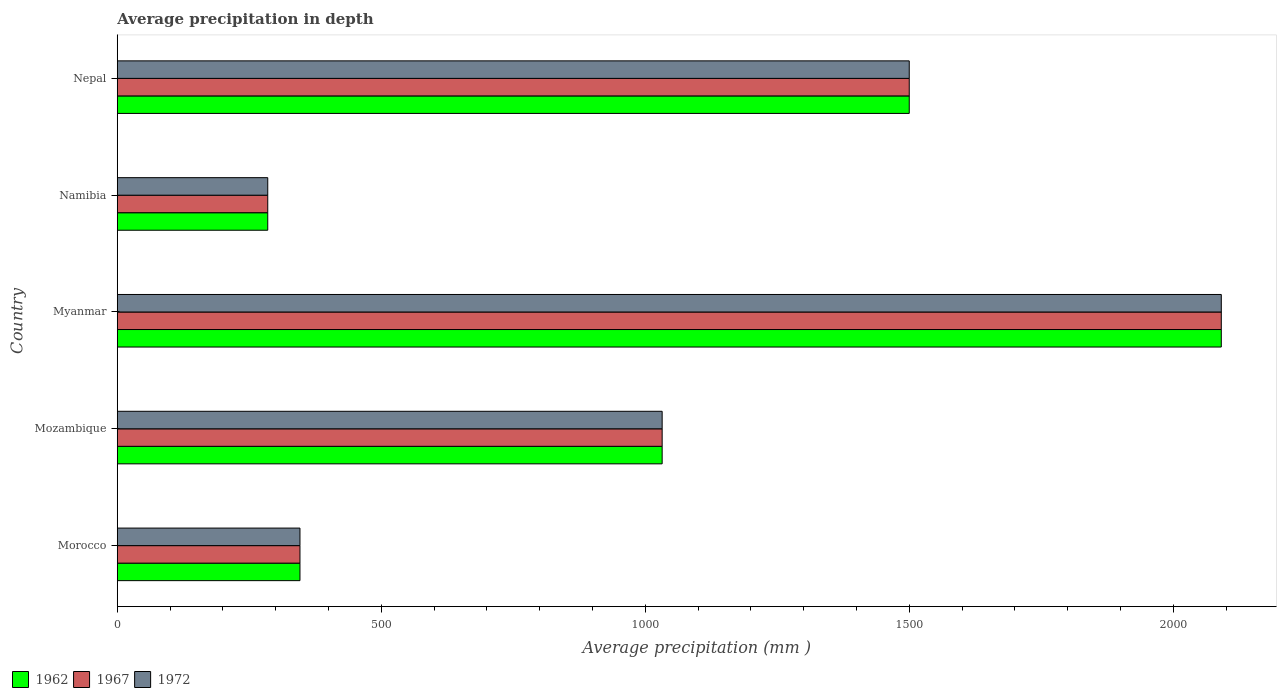Are the number of bars per tick equal to the number of legend labels?
Offer a very short reply. Yes. Are the number of bars on each tick of the Y-axis equal?
Your response must be concise. Yes. What is the label of the 3rd group of bars from the top?
Make the answer very short. Myanmar. In how many cases, is the number of bars for a given country not equal to the number of legend labels?
Provide a succinct answer. 0. What is the average precipitation in 1962 in Namibia?
Offer a terse response. 285. Across all countries, what is the maximum average precipitation in 1972?
Give a very brief answer. 2091. Across all countries, what is the minimum average precipitation in 1962?
Provide a short and direct response. 285. In which country was the average precipitation in 1962 maximum?
Your answer should be compact. Myanmar. In which country was the average precipitation in 1967 minimum?
Your answer should be compact. Namibia. What is the total average precipitation in 1967 in the graph?
Keep it short and to the point. 5254. What is the difference between the average precipitation in 1962 in Mozambique and that in Namibia?
Provide a short and direct response. 747. What is the difference between the average precipitation in 1967 in Namibia and the average precipitation in 1972 in Morocco?
Ensure brevity in your answer.  -61. What is the average average precipitation in 1962 per country?
Keep it short and to the point. 1050.8. What is the ratio of the average precipitation in 1962 in Mozambique to that in Namibia?
Provide a short and direct response. 3.62. What is the difference between the highest and the second highest average precipitation in 1972?
Make the answer very short. 591. What is the difference between the highest and the lowest average precipitation in 1972?
Make the answer very short. 1806. What does the 1st bar from the top in Myanmar represents?
Offer a very short reply. 1972. Is it the case that in every country, the sum of the average precipitation in 1962 and average precipitation in 1972 is greater than the average precipitation in 1967?
Offer a terse response. Yes. How many bars are there?
Make the answer very short. 15. Are the values on the major ticks of X-axis written in scientific E-notation?
Offer a very short reply. No. Does the graph contain any zero values?
Keep it short and to the point. No. What is the title of the graph?
Give a very brief answer. Average precipitation in depth. What is the label or title of the X-axis?
Your answer should be compact. Average precipitation (mm ). What is the Average precipitation (mm ) of 1962 in Morocco?
Give a very brief answer. 346. What is the Average precipitation (mm ) of 1967 in Morocco?
Provide a short and direct response. 346. What is the Average precipitation (mm ) of 1972 in Morocco?
Provide a succinct answer. 346. What is the Average precipitation (mm ) of 1962 in Mozambique?
Ensure brevity in your answer.  1032. What is the Average precipitation (mm ) of 1967 in Mozambique?
Your answer should be compact. 1032. What is the Average precipitation (mm ) of 1972 in Mozambique?
Keep it short and to the point. 1032. What is the Average precipitation (mm ) of 1962 in Myanmar?
Your answer should be compact. 2091. What is the Average precipitation (mm ) of 1967 in Myanmar?
Make the answer very short. 2091. What is the Average precipitation (mm ) in 1972 in Myanmar?
Your answer should be compact. 2091. What is the Average precipitation (mm ) in 1962 in Namibia?
Keep it short and to the point. 285. What is the Average precipitation (mm ) of 1967 in Namibia?
Offer a very short reply. 285. What is the Average precipitation (mm ) of 1972 in Namibia?
Make the answer very short. 285. What is the Average precipitation (mm ) of 1962 in Nepal?
Your response must be concise. 1500. What is the Average precipitation (mm ) of 1967 in Nepal?
Give a very brief answer. 1500. What is the Average precipitation (mm ) in 1972 in Nepal?
Ensure brevity in your answer.  1500. Across all countries, what is the maximum Average precipitation (mm ) of 1962?
Your answer should be compact. 2091. Across all countries, what is the maximum Average precipitation (mm ) of 1967?
Provide a succinct answer. 2091. Across all countries, what is the maximum Average precipitation (mm ) of 1972?
Provide a succinct answer. 2091. Across all countries, what is the minimum Average precipitation (mm ) in 1962?
Ensure brevity in your answer.  285. Across all countries, what is the minimum Average precipitation (mm ) of 1967?
Ensure brevity in your answer.  285. Across all countries, what is the minimum Average precipitation (mm ) of 1972?
Your answer should be compact. 285. What is the total Average precipitation (mm ) of 1962 in the graph?
Provide a succinct answer. 5254. What is the total Average precipitation (mm ) in 1967 in the graph?
Provide a succinct answer. 5254. What is the total Average precipitation (mm ) in 1972 in the graph?
Keep it short and to the point. 5254. What is the difference between the Average precipitation (mm ) of 1962 in Morocco and that in Mozambique?
Provide a succinct answer. -686. What is the difference between the Average precipitation (mm ) in 1967 in Morocco and that in Mozambique?
Keep it short and to the point. -686. What is the difference between the Average precipitation (mm ) in 1972 in Morocco and that in Mozambique?
Offer a terse response. -686. What is the difference between the Average precipitation (mm ) of 1962 in Morocco and that in Myanmar?
Offer a very short reply. -1745. What is the difference between the Average precipitation (mm ) in 1967 in Morocco and that in Myanmar?
Ensure brevity in your answer.  -1745. What is the difference between the Average precipitation (mm ) in 1972 in Morocco and that in Myanmar?
Provide a short and direct response. -1745. What is the difference between the Average precipitation (mm ) in 1967 in Morocco and that in Namibia?
Offer a very short reply. 61. What is the difference between the Average precipitation (mm ) in 1962 in Morocco and that in Nepal?
Keep it short and to the point. -1154. What is the difference between the Average precipitation (mm ) in 1967 in Morocco and that in Nepal?
Provide a succinct answer. -1154. What is the difference between the Average precipitation (mm ) in 1972 in Morocco and that in Nepal?
Offer a very short reply. -1154. What is the difference between the Average precipitation (mm ) in 1962 in Mozambique and that in Myanmar?
Give a very brief answer. -1059. What is the difference between the Average precipitation (mm ) of 1967 in Mozambique and that in Myanmar?
Provide a succinct answer. -1059. What is the difference between the Average precipitation (mm ) of 1972 in Mozambique and that in Myanmar?
Make the answer very short. -1059. What is the difference between the Average precipitation (mm ) in 1962 in Mozambique and that in Namibia?
Offer a very short reply. 747. What is the difference between the Average precipitation (mm ) in 1967 in Mozambique and that in Namibia?
Your answer should be very brief. 747. What is the difference between the Average precipitation (mm ) in 1972 in Mozambique and that in Namibia?
Your response must be concise. 747. What is the difference between the Average precipitation (mm ) in 1962 in Mozambique and that in Nepal?
Your answer should be very brief. -468. What is the difference between the Average precipitation (mm ) in 1967 in Mozambique and that in Nepal?
Give a very brief answer. -468. What is the difference between the Average precipitation (mm ) in 1972 in Mozambique and that in Nepal?
Your answer should be compact. -468. What is the difference between the Average precipitation (mm ) in 1962 in Myanmar and that in Namibia?
Your response must be concise. 1806. What is the difference between the Average precipitation (mm ) of 1967 in Myanmar and that in Namibia?
Keep it short and to the point. 1806. What is the difference between the Average precipitation (mm ) in 1972 in Myanmar and that in Namibia?
Provide a short and direct response. 1806. What is the difference between the Average precipitation (mm ) in 1962 in Myanmar and that in Nepal?
Your answer should be very brief. 591. What is the difference between the Average precipitation (mm ) in 1967 in Myanmar and that in Nepal?
Make the answer very short. 591. What is the difference between the Average precipitation (mm ) in 1972 in Myanmar and that in Nepal?
Ensure brevity in your answer.  591. What is the difference between the Average precipitation (mm ) in 1962 in Namibia and that in Nepal?
Offer a terse response. -1215. What is the difference between the Average precipitation (mm ) of 1967 in Namibia and that in Nepal?
Offer a terse response. -1215. What is the difference between the Average precipitation (mm ) of 1972 in Namibia and that in Nepal?
Provide a succinct answer. -1215. What is the difference between the Average precipitation (mm ) in 1962 in Morocco and the Average precipitation (mm ) in 1967 in Mozambique?
Keep it short and to the point. -686. What is the difference between the Average precipitation (mm ) of 1962 in Morocco and the Average precipitation (mm ) of 1972 in Mozambique?
Offer a terse response. -686. What is the difference between the Average precipitation (mm ) of 1967 in Morocco and the Average precipitation (mm ) of 1972 in Mozambique?
Your answer should be very brief. -686. What is the difference between the Average precipitation (mm ) in 1962 in Morocco and the Average precipitation (mm ) in 1967 in Myanmar?
Your answer should be compact. -1745. What is the difference between the Average precipitation (mm ) in 1962 in Morocco and the Average precipitation (mm ) in 1972 in Myanmar?
Give a very brief answer. -1745. What is the difference between the Average precipitation (mm ) in 1967 in Morocco and the Average precipitation (mm ) in 1972 in Myanmar?
Keep it short and to the point. -1745. What is the difference between the Average precipitation (mm ) of 1962 in Morocco and the Average precipitation (mm ) of 1967 in Nepal?
Your answer should be very brief. -1154. What is the difference between the Average precipitation (mm ) in 1962 in Morocco and the Average precipitation (mm ) in 1972 in Nepal?
Give a very brief answer. -1154. What is the difference between the Average precipitation (mm ) of 1967 in Morocco and the Average precipitation (mm ) of 1972 in Nepal?
Your response must be concise. -1154. What is the difference between the Average precipitation (mm ) in 1962 in Mozambique and the Average precipitation (mm ) in 1967 in Myanmar?
Offer a very short reply. -1059. What is the difference between the Average precipitation (mm ) in 1962 in Mozambique and the Average precipitation (mm ) in 1972 in Myanmar?
Provide a succinct answer. -1059. What is the difference between the Average precipitation (mm ) in 1967 in Mozambique and the Average precipitation (mm ) in 1972 in Myanmar?
Your answer should be compact. -1059. What is the difference between the Average precipitation (mm ) of 1962 in Mozambique and the Average precipitation (mm ) of 1967 in Namibia?
Keep it short and to the point. 747. What is the difference between the Average precipitation (mm ) in 1962 in Mozambique and the Average precipitation (mm ) in 1972 in Namibia?
Ensure brevity in your answer.  747. What is the difference between the Average precipitation (mm ) of 1967 in Mozambique and the Average precipitation (mm ) of 1972 in Namibia?
Offer a very short reply. 747. What is the difference between the Average precipitation (mm ) of 1962 in Mozambique and the Average precipitation (mm ) of 1967 in Nepal?
Give a very brief answer. -468. What is the difference between the Average precipitation (mm ) of 1962 in Mozambique and the Average precipitation (mm ) of 1972 in Nepal?
Make the answer very short. -468. What is the difference between the Average precipitation (mm ) in 1967 in Mozambique and the Average precipitation (mm ) in 1972 in Nepal?
Your response must be concise. -468. What is the difference between the Average precipitation (mm ) of 1962 in Myanmar and the Average precipitation (mm ) of 1967 in Namibia?
Keep it short and to the point. 1806. What is the difference between the Average precipitation (mm ) in 1962 in Myanmar and the Average precipitation (mm ) in 1972 in Namibia?
Offer a terse response. 1806. What is the difference between the Average precipitation (mm ) of 1967 in Myanmar and the Average precipitation (mm ) of 1972 in Namibia?
Offer a very short reply. 1806. What is the difference between the Average precipitation (mm ) in 1962 in Myanmar and the Average precipitation (mm ) in 1967 in Nepal?
Provide a short and direct response. 591. What is the difference between the Average precipitation (mm ) of 1962 in Myanmar and the Average precipitation (mm ) of 1972 in Nepal?
Your answer should be compact. 591. What is the difference between the Average precipitation (mm ) of 1967 in Myanmar and the Average precipitation (mm ) of 1972 in Nepal?
Give a very brief answer. 591. What is the difference between the Average precipitation (mm ) in 1962 in Namibia and the Average precipitation (mm ) in 1967 in Nepal?
Your answer should be compact. -1215. What is the difference between the Average precipitation (mm ) of 1962 in Namibia and the Average precipitation (mm ) of 1972 in Nepal?
Your response must be concise. -1215. What is the difference between the Average precipitation (mm ) in 1967 in Namibia and the Average precipitation (mm ) in 1972 in Nepal?
Ensure brevity in your answer.  -1215. What is the average Average precipitation (mm ) of 1962 per country?
Provide a succinct answer. 1050.8. What is the average Average precipitation (mm ) of 1967 per country?
Provide a succinct answer. 1050.8. What is the average Average precipitation (mm ) in 1972 per country?
Your response must be concise. 1050.8. What is the difference between the Average precipitation (mm ) of 1962 and Average precipitation (mm ) of 1967 in Morocco?
Give a very brief answer. 0. What is the difference between the Average precipitation (mm ) in 1962 and Average precipitation (mm ) in 1972 in Morocco?
Offer a terse response. 0. What is the difference between the Average precipitation (mm ) of 1967 and Average precipitation (mm ) of 1972 in Morocco?
Your answer should be compact. 0. What is the difference between the Average precipitation (mm ) of 1967 and Average precipitation (mm ) of 1972 in Mozambique?
Provide a short and direct response. 0. What is the difference between the Average precipitation (mm ) of 1962 and Average precipitation (mm ) of 1967 in Namibia?
Ensure brevity in your answer.  0. What is the difference between the Average precipitation (mm ) of 1962 and Average precipitation (mm ) of 1972 in Namibia?
Offer a very short reply. 0. What is the difference between the Average precipitation (mm ) in 1962 and Average precipitation (mm ) in 1972 in Nepal?
Your answer should be very brief. 0. What is the ratio of the Average precipitation (mm ) in 1962 in Morocco to that in Mozambique?
Offer a very short reply. 0.34. What is the ratio of the Average precipitation (mm ) in 1967 in Morocco to that in Mozambique?
Keep it short and to the point. 0.34. What is the ratio of the Average precipitation (mm ) in 1972 in Morocco to that in Mozambique?
Your response must be concise. 0.34. What is the ratio of the Average precipitation (mm ) of 1962 in Morocco to that in Myanmar?
Ensure brevity in your answer.  0.17. What is the ratio of the Average precipitation (mm ) in 1967 in Morocco to that in Myanmar?
Offer a very short reply. 0.17. What is the ratio of the Average precipitation (mm ) of 1972 in Morocco to that in Myanmar?
Keep it short and to the point. 0.17. What is the ratio of the Average precipitation (mm ) of 1962 in Morocco to that in Namibia?
Give a very brief answer. 1.21. What is the ratio of the Average precipitation (mm ) in 1967 in Morocco to that in Namibia?
Give a very brief answer. 1.21. What is the ratio of the Average precipitation (mm ) in 1972 in Morocco to that in Namibia?
Ensure brevity in your answer.  1.21. What is the ratio of the Average precipitation (mm ) in 1962 in Morocco to that in Nepal?
Give a very brief answer. 0.23. What is the ratio of the Average precipitation (mm ) of 1967 in Morocco to that in Nepal?
Ensure brevity in your answer.  0.23. What is the ratio of the Average precipitation (mm ) of 1972 in Morocco to that in Nepal?
Provide a short and direct response. 0.23. What is the ratio of the Average precipitation (mm ) in 1962 in Mozambique to that in Myanmar?
Give a very brief answer. 0.49. What is the ratio of the Average precipitation (mm ) in 1967 in Mozambique to that in Myanmar?
Your answer should be very brief. 0.49. What is the ratio of the Average precipitation (mm ) in 1972 in Mozambique to that in Myanmar?
Make the answer very short. 0.49. What is the ratio of the Average precipitation (mm ) of 1962 in Mozambique to that in Namibia?
Provide a short and direct response. 3.62. What is the ratio of the Average precipitation (mm ) in 1967 in Mozambique to that in Namibia?
Your response must be concise. 3.62. What is the ratio of the Average precipitation (mm ) in 1972 in Mozambique to that in Namibia?
Keep it short and to the point. 3.62. What is the ratio of the Average precipitation (mm ) of 1962 in Mozambique to that in Nepal?
Provide a succinct answer. 0.69. What is the ratio of the Average precipitation (mm ) of 1967 in Mozambique to that in Nepal?
Provide a short and direct response. 0.69. What is the ratio of the Average precipitation (mm ) of 1972 in Mozambique to that in Nepal?
Provide a succinct answer. 0.69. What is the ratio of the Average precipitation (mm ) in 1962 in Myanmar to that in Namibia?
Keep it short and to the point. 7.34. What is the ratio of the Average precipitation (mm ) of 1967 in Myanmar to that in Namibia?
Offer a terse response. 7.34. What is the ratio of the Average precipitation (mm ) in 1972 in Myanmar to that in Namibia?
Offer a very short reply. 7.34. What is the ratio of the Average precipitation (mm ) of 1962 in Myanmar to that in Nepal?
Give a very brief answer. 1.39. What is the ratio of the Average precipitation (mm ) in 1967 in Myanmar to that in Nepal?
Provide a short and direct response. 1.39. What is the ratio of the Average precipitation (mm ) in 1972 in Myanmar to that in Nepal?
Your answer should be compact. 1.39. What is the ratio of the Average precipitation (mm ) in 1962 in Namibia to that in Nepal?
Provide a short and direct response. 0.19. What is the ratio of the Average precipitation (mm ) in 1967 in Namibia to that in Nepal?
Provide a succinct answer. 0.19. What is the ratio of the Average precipitation (mm ) of 1972 in Namibia to that in Nepal?
Offer a terse response. 0.19. What is the difference between the highest and the second highest Average precipitation (mm ) in 1962?
Ensure brevity in your answer.  591. What is the difference between the highest and the second highest Average precipitation (mm ) of 1967?
Your response must be concise. 591. What is the difference between the highest and the second highest Average precipitation (mm ) in 1972?
Give a very brief answer. 591. What is the difference between the highest and the lowest Average precipitation (mm ) in 1962?
Make the answer very short. 1806. What is the difference between the highest and the lowest Average precipitation (mm ) of 1967?
Your response must be concise. 1806. What is the difference between the highest and the lowest Average precipitation (mm ) of 1972?
Your response must be concise. 1806. 